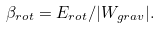<formula> <loc_0><loc_0><loc_500><loc_500>\beta _ { r o t } = E _ { r o t } / | W _ { g r a v } | .</formula> 